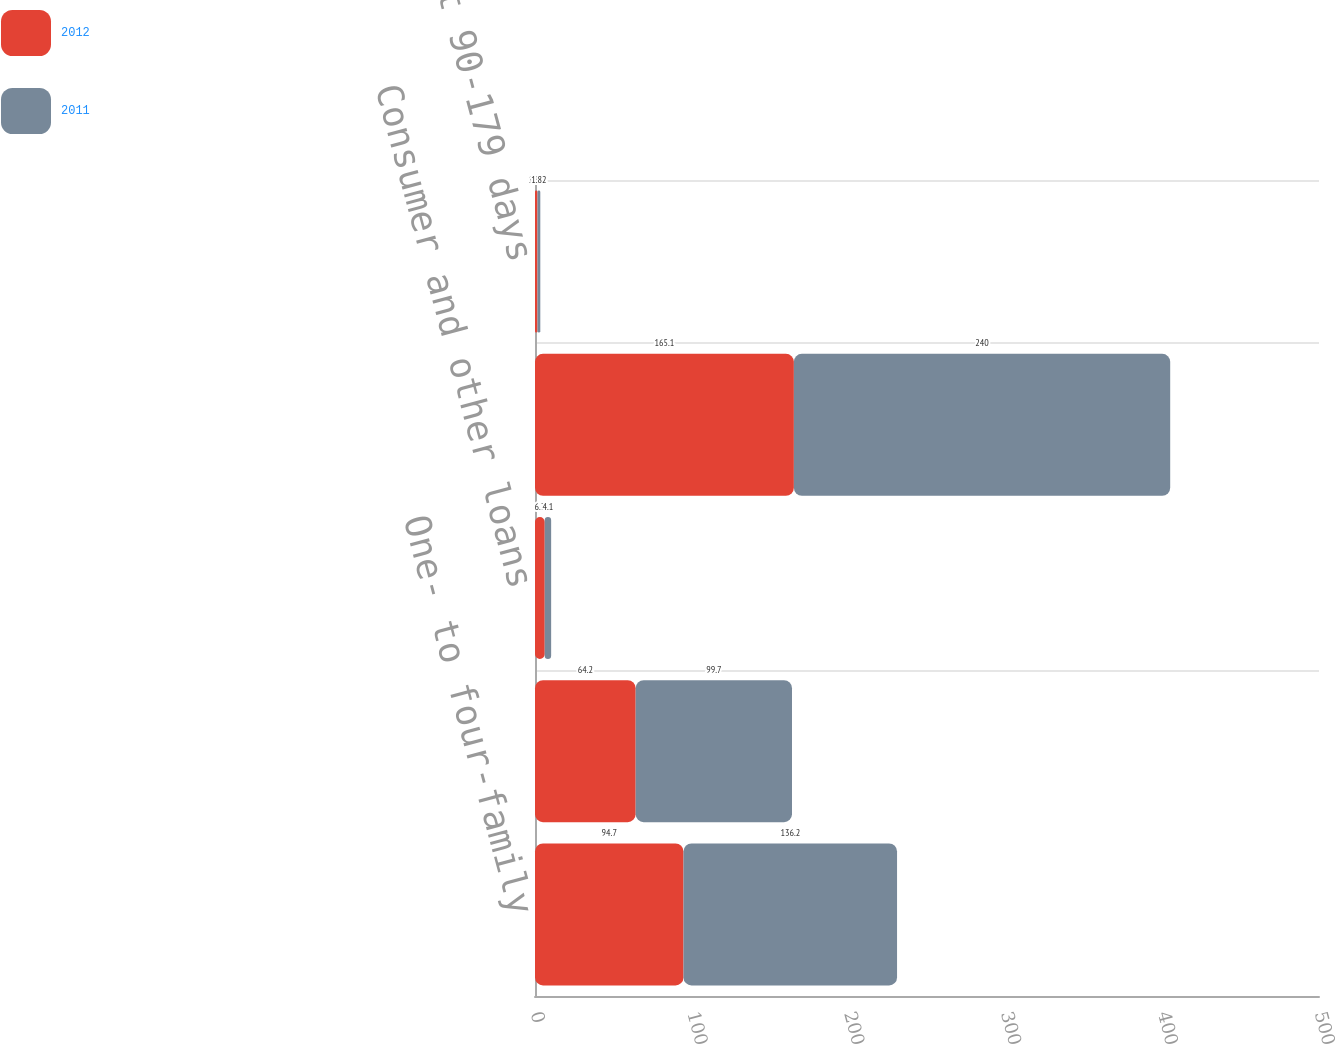Convert chart. <chart><loc_0><loc_0><loc_500><loc_500><stacked_bar_chart><ecel><fcel>One- to four-family<fcel>Home equity<fcel>Consumer and other loans<fcel>Total loans delinquent 90-179<fcel>Loans delinquent 90-179 days<nl><fcel>2012<fcel>94.7<fcel>64.2<fcel>6.2<fcel>165.1<fcel>1.56<nl><fcel>2011<fcel>136.2<fcel>99.7<fcel>4.1<fcel>240<fcel>1.82<nl></chart> 